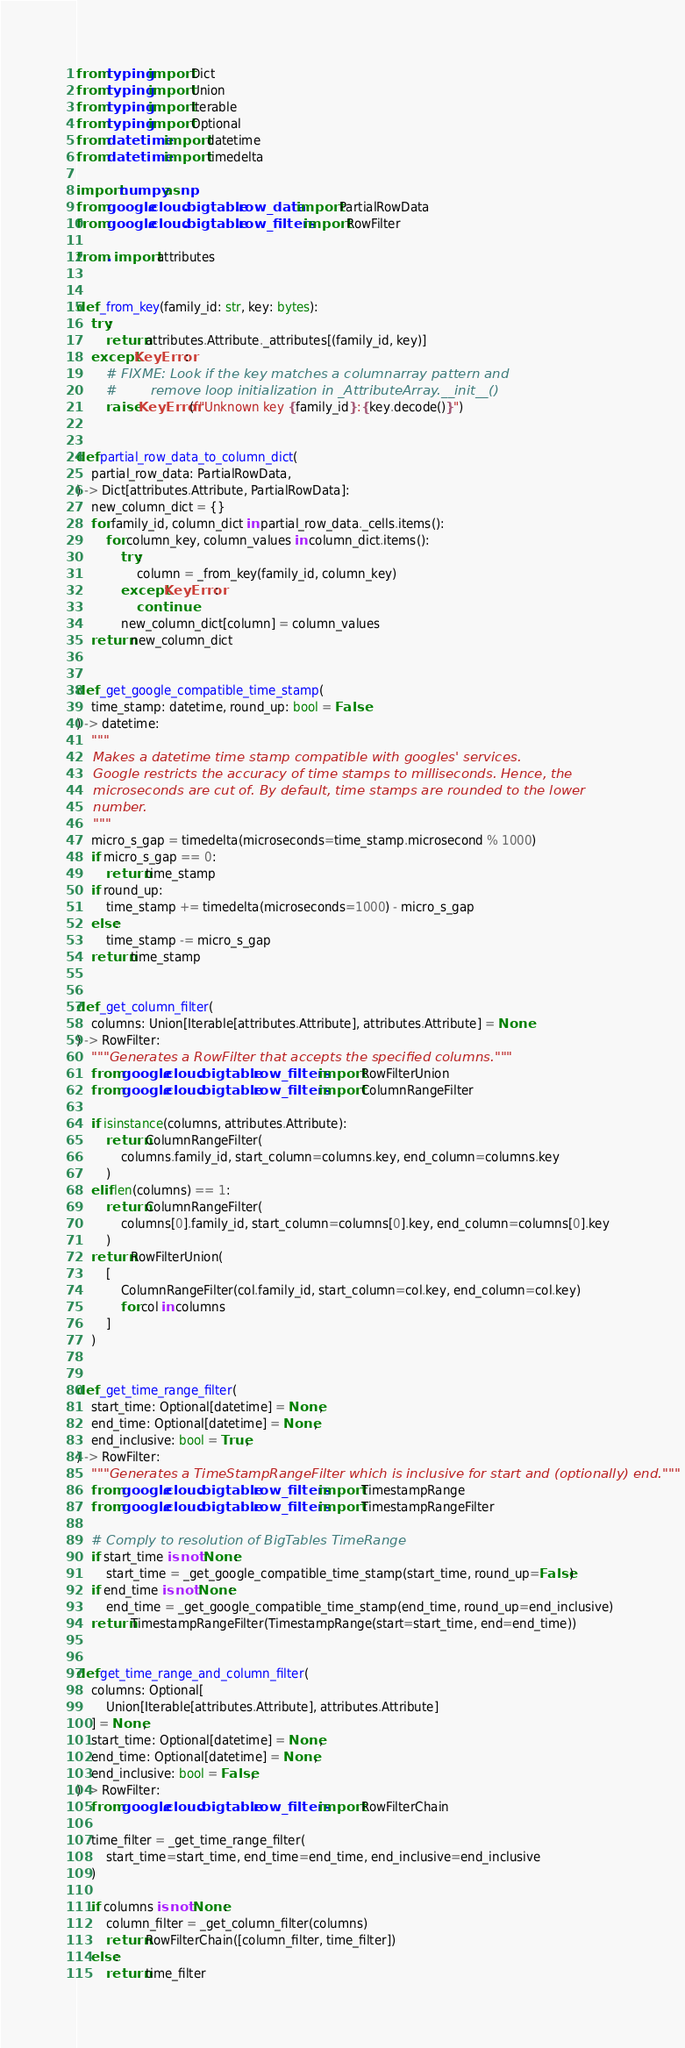Convert code to text. <code><loc_0><loc_0><loc_500><loc_500><_Python_>from typing import Dict
from typing import Union
from typing import Iterable
from typing import Optional
from datetime import datetime
from datetime import timedelta

import numpy as np
from google.cloud.bigtable.row_data import PartialRowData
from google.cloud.bigtable.row_filters import RowFilter

from . import attributes


def _from_key(family_id: str, key: bytes):
    try:
        return attributes.Attribute._attributes[(family_id, key)]
    except KeyError:
        # FIXME: Look if the key matches a columnarray pattern and
        #        remove loop initialization in _AttributeArray.__init__()
        raise KeyError(f"Unknown key {family_id}:{key.decode()}")


def partial_row_data_to_column_dict(
    partial_row_data: PartialRowData,
) -> Dict[attributes.Attribute, PartialRowData]:
    new_column_dict = {}
    for family_id, column_dict in partial_row_data._cells.items():
        for column_key, column_values in column_dict.items():
            try:
                column = _from_key(family_id, column_key)
            except KeyError:
                continue
            new_column_dict[column] = column_values
    return new_column_dict


def _get_google_compatible_time_stamp(
    time_stamp: datetime, round_up: bool = False
) -> datetime:
    """
    Makes a datetime time stamp compatible with googles' services.
    Google restricts the accuracy of time stamps to milliseconds. Hence, the
    microseconds are cut of. By default, time stamps are rounded to the lower
    number.
    """
    micro_s_gap = timedelta(microseconds=time_stamp.microsecond % 1000)
    if micro_s_gap == 0:
        return time_stamp
    if round_up:
        time_stamp += timedelta(microseconds=1000) - micro_s_gap
    else:
        time_stamp -= micro_s_gap
    return time_stamp


def _get_column_filter(
    columns: Union[Iterable[attributes.Attribute], attributes.Attribute] = None
) -> RowFilter:
    """Generates a RowFilter that accepts the specified columns."""
    from google.cloud.bigtable.row_filters import RowFilterUnion
    from google.cloud.bigtable.row_filters import ColumnRangeFilter

    if isinstance(columns, attributes.Attribute):
        return ColumnRangeFilter(
            columns.family_id, start_column=columns.key, end_column=columns.key
        )
    elif len(columns) == 1:
        return ColumnRangeFilter(
            columns[0].family_id, start_column=columns[0].key, end_column=columns[0].key
        )
    return RowFilterUnion(
        [
            ColumnRangeFilter(col.family_id, start_column=col.key, end_column=col.key)
            for col in columns
        ]
    )


def _get_time_range_filter(
    start_time: Optional[datetime] = None,
    end_time: Optional[datetime] = None,
    end_inclusive: bool = True,
) -> RowFilter:
    """Generates a TimeStampRangeFilter which is inclusive for start and (optionally) end."""
    from google.cloud.bigtable.row_filters import TimestampRange
    from google.cloud.bigtable.row_filters import TimestampRangeFilter

    # Comply to resolution of BigTables TimeRange
    if start_time is not None:
        start_time = _get_google_compatible_time_stamp(start_time, round_up=False)
    if end_time is not None:
        end_time = _get_google_compatible_time_stamp(end_time, round_up=end_inclusive)
    return TimestampRangeFilter(TimestampRange(start=start_time, end=end_time))


def get_time_range_and_column_filter(
    columns: Optional[
        Union[Iterable[attributes.Attribute], attributes.Attribute]
    ] = None,
    start_time: Optional[datetime] = None,
    end_time: Optional[datetime] = None,
    end_inclusive: bool = False,
) -> RowFilter:
    from google.cloud.bigtable.row_filters import RowFilterChain

    time_filter = _get_time_range_filter(
        start_time=start_time, end_time=end_time, end_inclusive=end_inclusive
    )

    if columns is not None:
        column_filter = _get_column_filter(columns)
        return RowFilterChain([column_filter, time_filter])
    else:
        return time_filter
</code> 